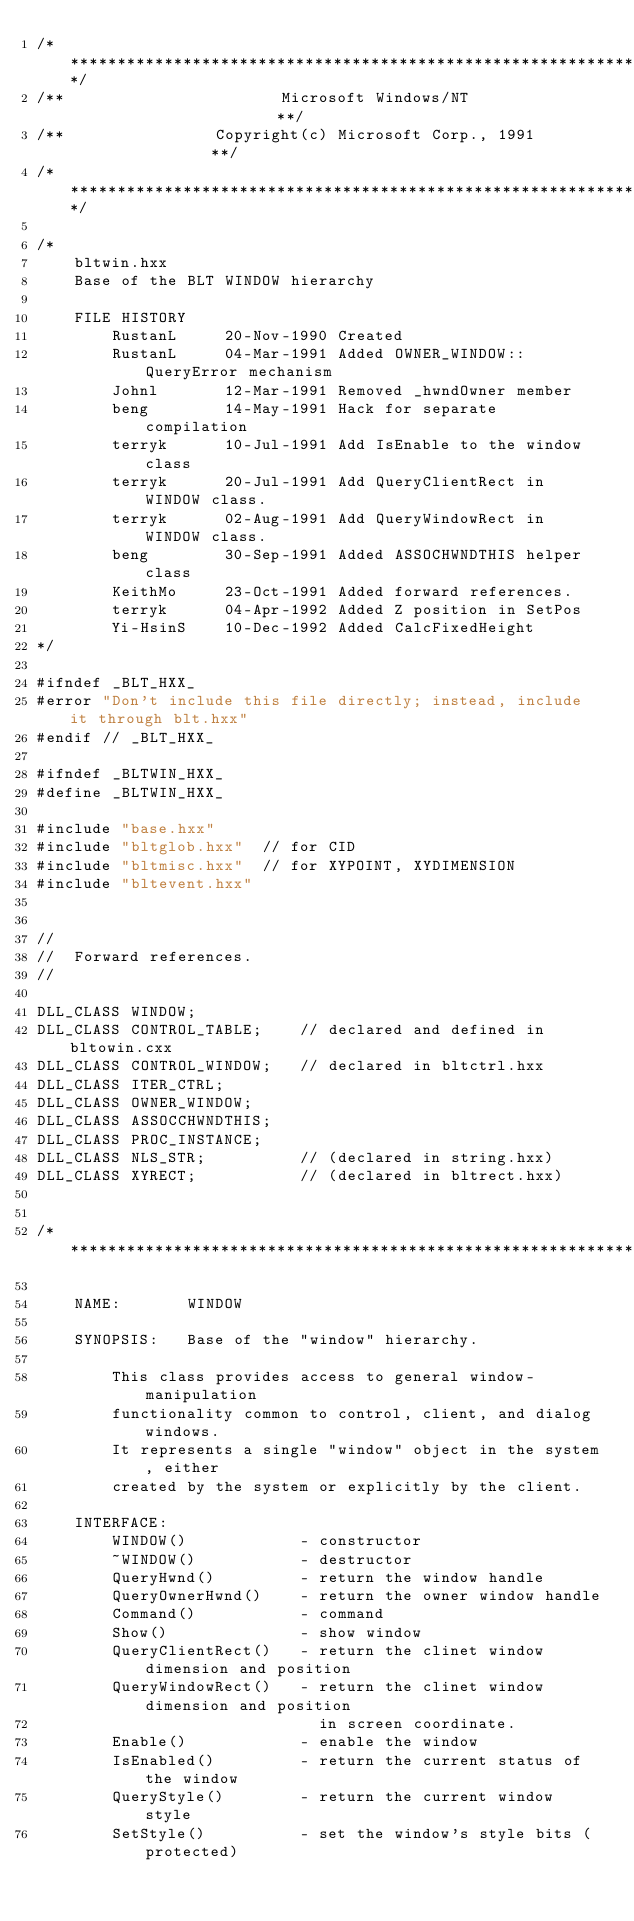Convert code to text. <code><loc_0><loc_0><loc_500><loc_500><_C++_>/**********************************************************************/
/**                       Microsoft Windows/NT                       **/
/**                Copyright(c) Microsoft Corp., 1991                **/
/**********************************************************************/

/*
    bltwin.hxx
    Base of the BLT WINDOW hierarchy

    FILE HISTORY
        RustanL     20-Nov-1990 Created
        RustanL     04-Mar-1991 Added OWNER_WINDOW::QueryError mechanism
        Johnl       12-Mar-1991 Removed _hwndOwner member
        beng        14-May-1991 Hack for separate compilation
        terryk      10-Jul-1991 Add IsEnable to the window class
        terryk      20-Jul-1991 Add QueryClientRect in WINDOW class.
        terryk      02-Aug-1991 Add QueryWindowRect in WINDOW class.
        beng        30-Sep-1991 Added ASSOCHWNDTHIS helper class
        KeithMo     23-Oct-1991 Added forward references.
        terryk      04-Apr-1992 Added Z position in SetPos
        Yi-HsinS    10-Dec-1992 Added CalcFixedHeight
*/

#ifndef _BLT_HXX_
#error "Don't include this file directly; instead, include it through blt.hxx"
#endif // _BLT_HXX_

#ifndef _BLTWIN_HXX_
#define _BLTWIN_HXX_

#include "base.hxx"
#include "bltglob.hxx"  // for CID
#include "bltmisc.hxx"  // for XYPOINT, XYDIMENSION
#include "bltevent.hxx"


//
//  Forward references.
//

DLL_CLASS WINDOW;
DLL_CLASS CONTROL_TABLE;    // declared and defined in bltowin.cxx
DLL_CLASS CONTROL_WINDOW;   // declared in bltctrl.hxx
DLL_CLASS ITER_CTRL;
DLL_CLASS OWNER_WINDOW;
DLL_CLASS ASSOCCHWNDTHIS;
DLL_CLASS PROC_INSTANCE;
DLL_CLASS NLS_STR;          // (declared in string.hxx)
DLL_CLASS XYRECT;           // (declared in bltrect.hxx)


/******************************************************************

    NAME:       WINDOW

    SYNOPSIS:   Base of the "window" hierarchy.

        This class provides access to general window-manipulation
        functionality common to control, client, and dialog windows.
        It represents a single "window" object in the system, either
        created by the system or explicitly by the client.

    INTERFACE:
        WINDOW()            - constructor
        ~WINDOW()           - destructor
        QueryHwnd()         - return the window handle
        QueryOwnerHwnd()    - return the owner window handle
        Command()           - command
        Show()              - show window
        QueryClientRect()   - return the clinet window dimension and position
        QueryWindowRect()   - return the clinet window dimension and position
                              in screen coordinate.
        Enable()            - enable the window
        IsEnabled()         - return the current status of the window
        QueryStyle()        - return the current window style
        SetStyle()          - set the window's style bits (protected)</code> 